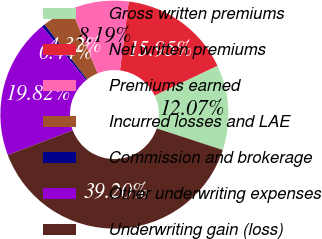Convert chart. <chart><loc_0><loc_0><loc_500><loc_500><pie_chart><fcel>Gross written premiums<fcel>Net written premiums<fcel>Premiums earned<fcel>Incurred losses and LAE<fcel>Commission and brokerage<fcel>Other underwriting expenses<fcel>Underwriting gain (loss)<nl><fcel>12.07%<fcel>15.95%<fcel>8.19%<fcel>4.32%<fcel>0.44%<fcel>19.82%<fcel>39.2%<nl></chart> 